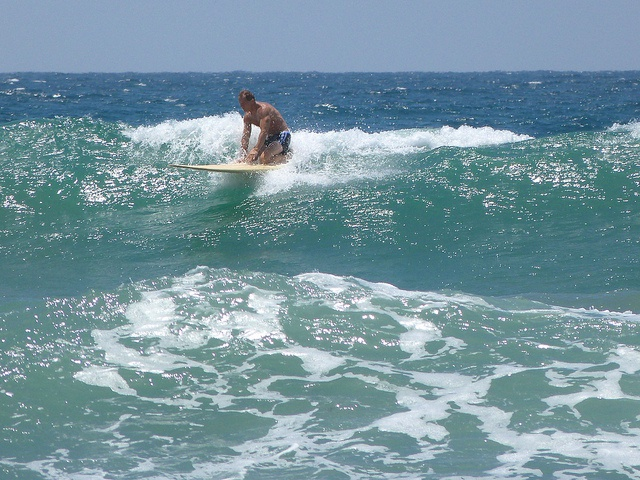Describe the objects in this image and their specific colors. I can see people in darkgray, gray, and black tones and surfboard in darkgray, beige, and gray tones in this image. 